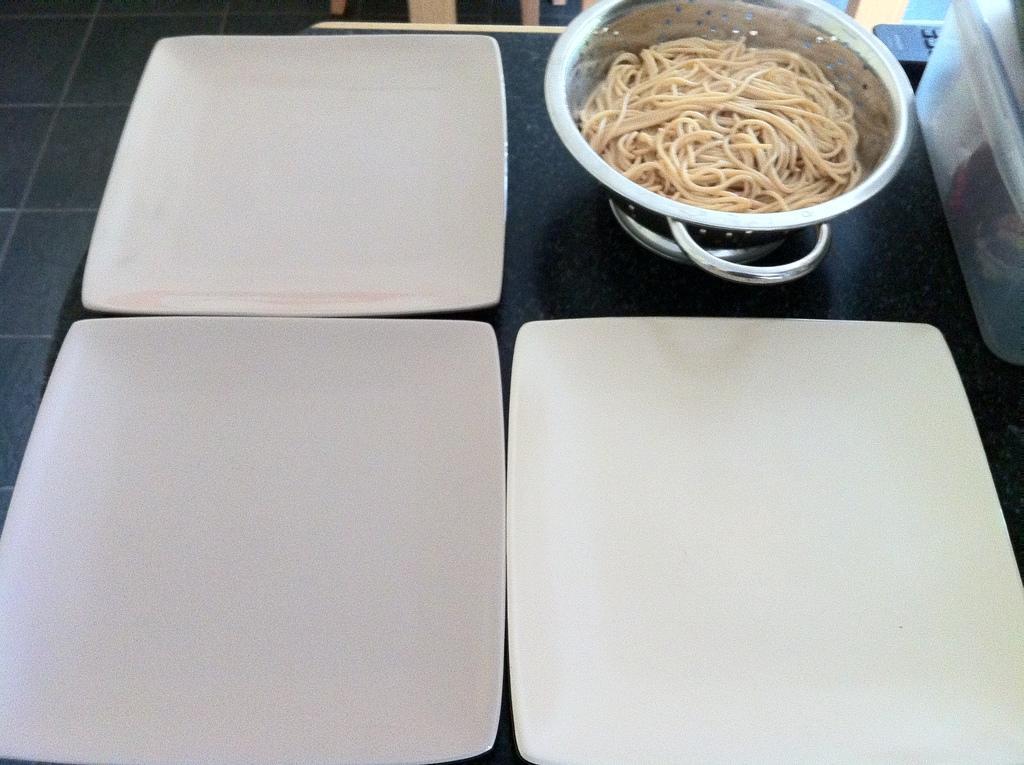Could you give a brief overview of what you see in this image? In this picture we can see a bowl with noodles in it, three plates, box, remote and these all are placed on the platform and in the background we can see some objects. 